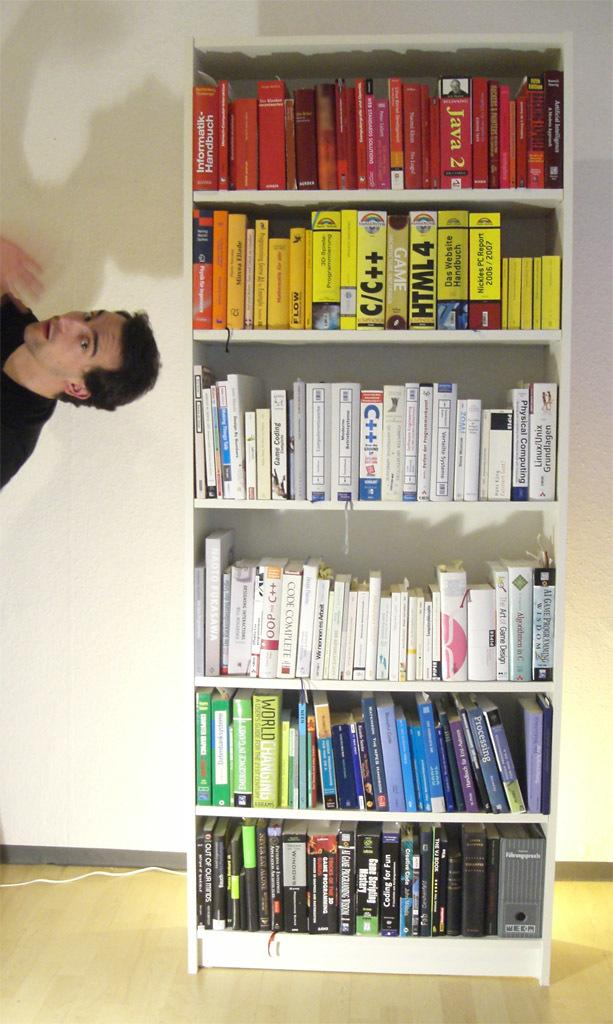<image>
Write a terse but informative summary of the picture. A Java 2 book sits with other red books on this color-coded shelf. 